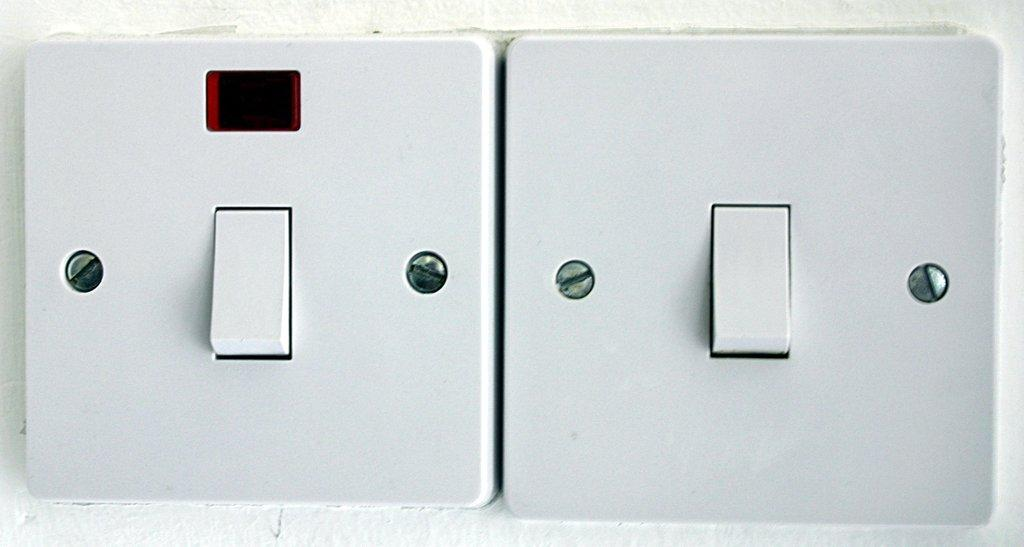How many switches are visible in the image? There are two switches in the image. What can be said about the color of the switches? The switches are white in color. What type of church is depicted in the image? There is no church present in the image; it only features two white switches. 